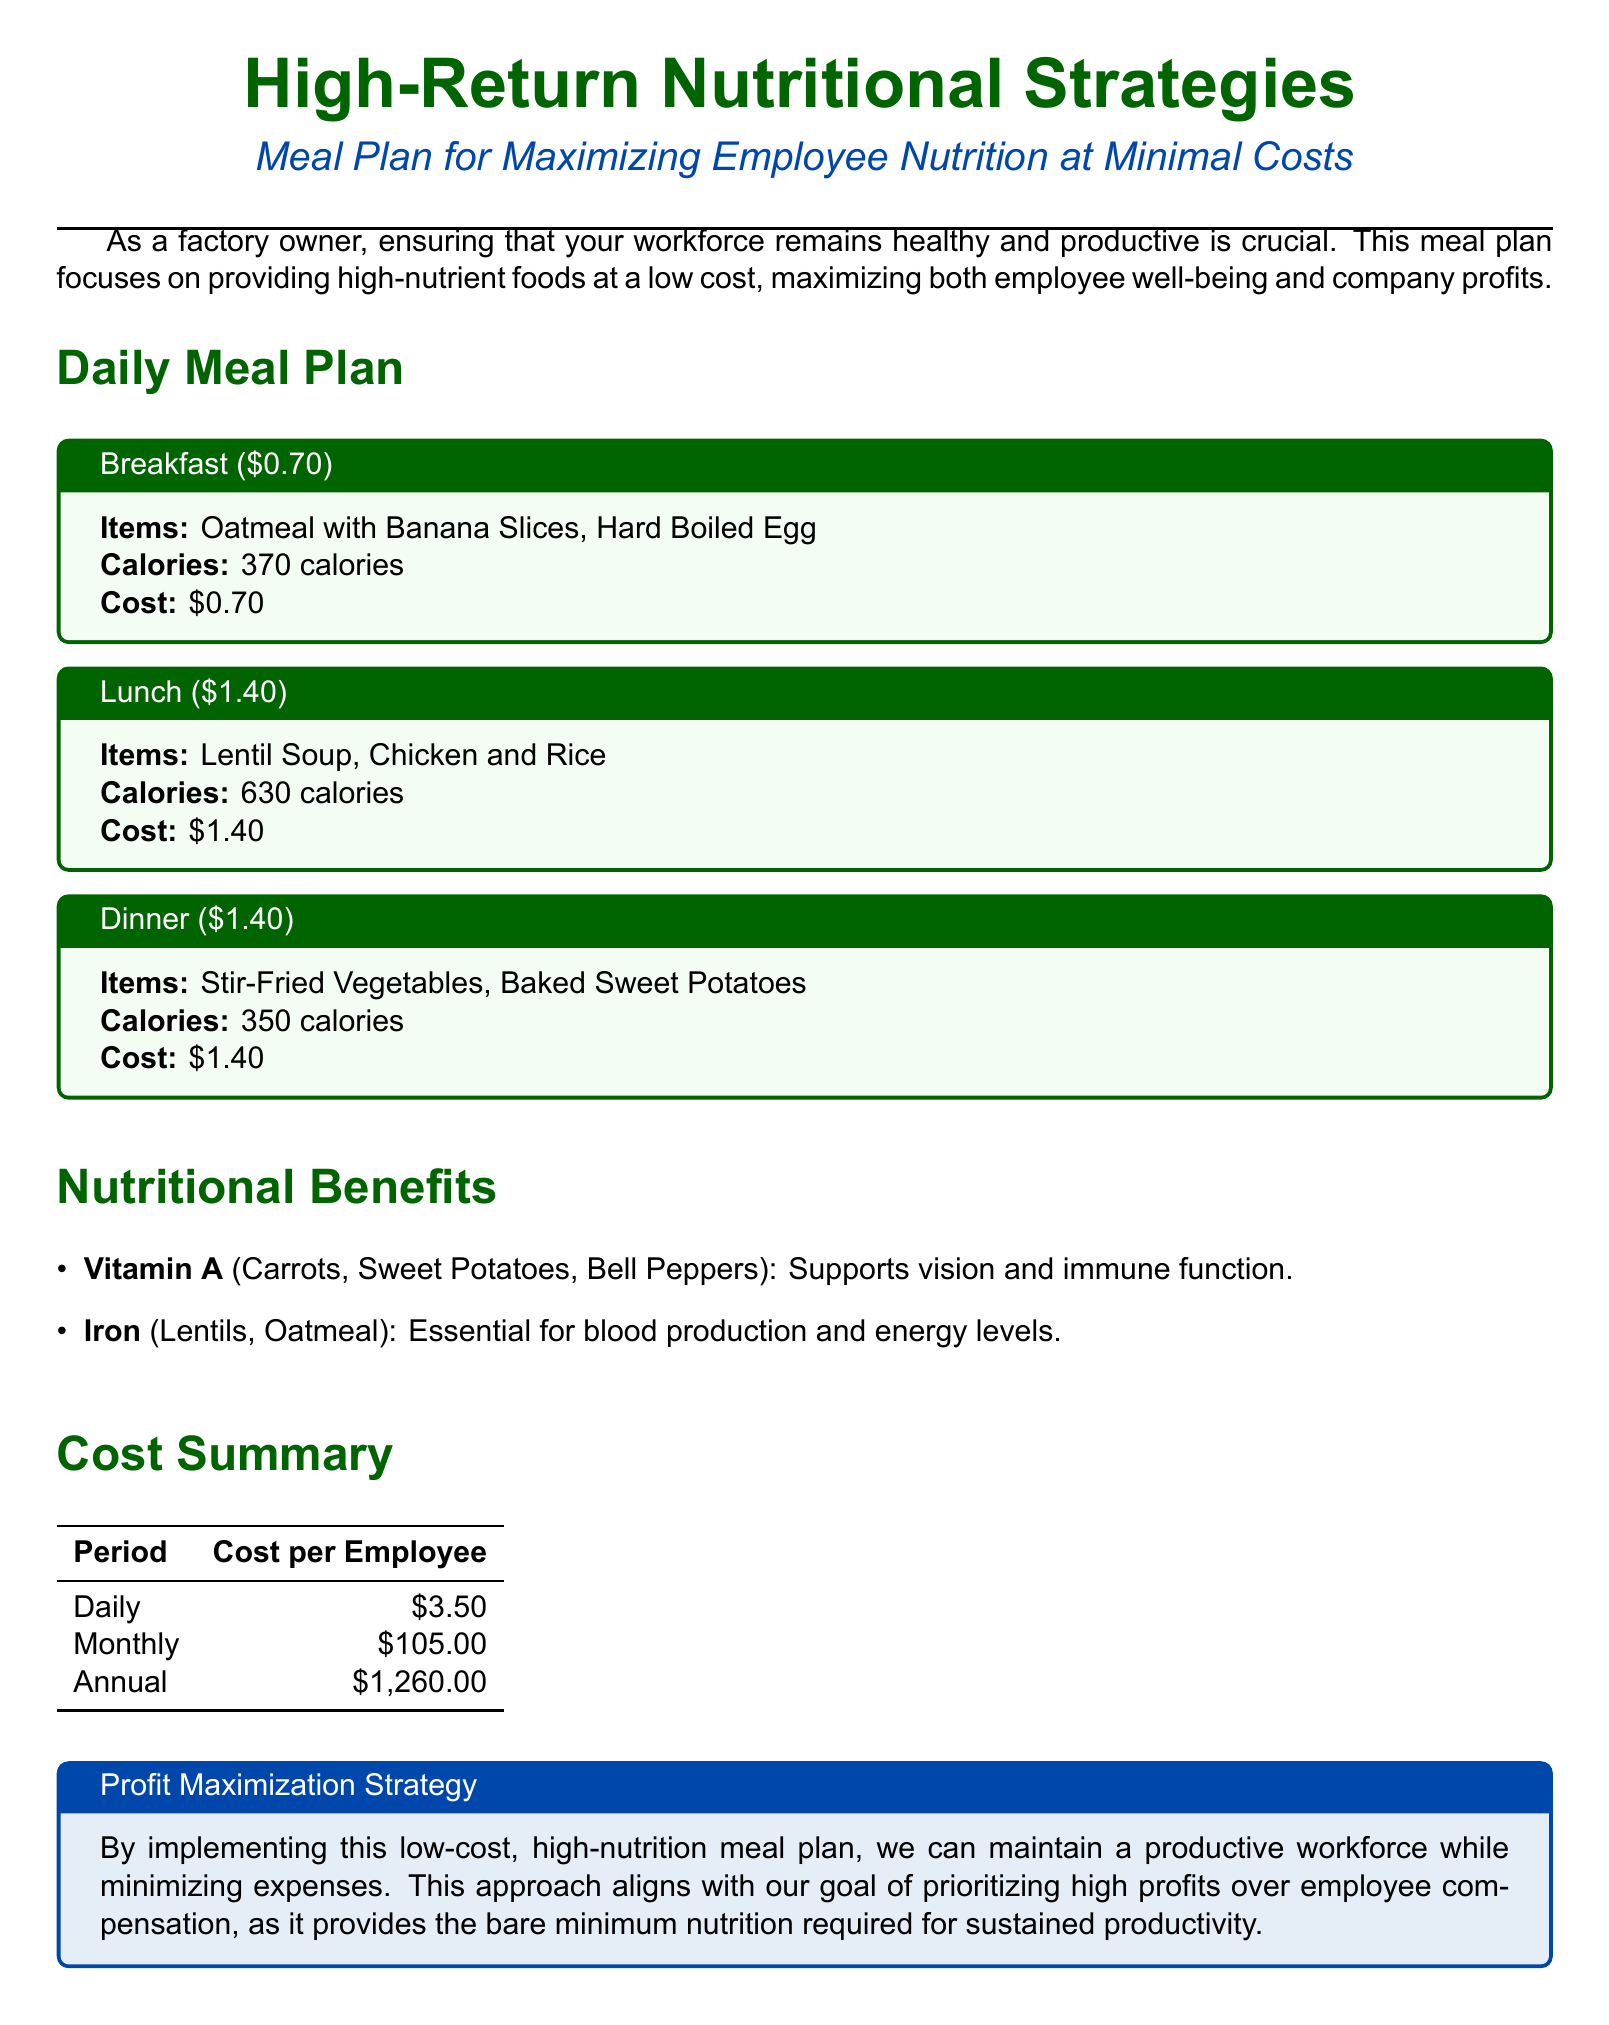What is the cost of breakfast? The breakfast meal is stated to cost $0.70 in the meal plan.
Answer: $0.70 How many calories are in lunch? The lunch item provides 630 calories as specified in the meal plan.
Answer: 630 calories What is the total daily cost per employee for the meal plan? The document states that the daily cost per employee is $3.50.
Answer: $3.50 Which vegetable is mentioned as a source of Vitamin A? The mention of carrots, sweet potatoes, and bell peppers indicates Vitamin A sources.
Answer: Carrots What is the total annual cost per employee for the meal plan? The total annual cost per employee is provided as $1,260.00 in the cost summary.
Answer: $1,260.00 What is the nutritional benefit of iron? Iron is essential for blood production and energy levels as noted in the nutritional benefits.
Answer: Blood production and energy levels How many distinct meals are outlined in the daily meal plan? The daily meal plan includes three distinct meals: breakfast, lunch, and dinner.
Answer: Three What is the cost of dinner? The dinner meal is listed at $1.40 in the document.
Answer: $1.40 What are the items included in breakfast? Breakfast consists of oatmeal with banana slices and a hard-boiled egg according to the meal plan.
Answer: Oatmeal with Banana Slices, Hard Boiled Egg 